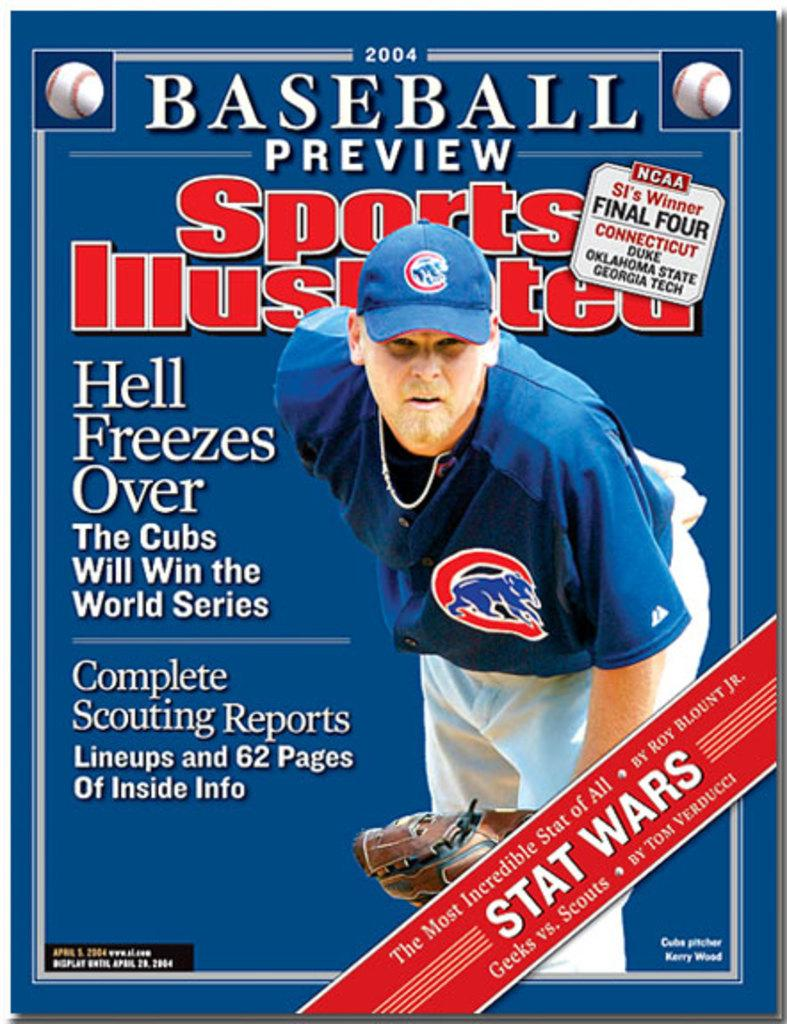<image>
Write a terse but informative summary of the picture. The front of a Sports Illustrated magazine that says Baseball Preview. 